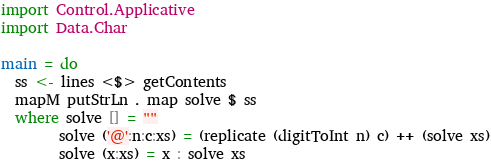Convert code to text. <code><loc_0><loc_0><loc_500><loc_500><_Haskell_>import Control.Applicative
import Data.Char

main = do
  ss <- lines <$> getContents
  mapM putStrLn . map solve $ ss
  where solve [] = ""
        solve ('@':n:c:xs) = (replicate (digitToInt n) c) ++ (solve xs)
        solve (x:xs) = x : solve xs</code> 